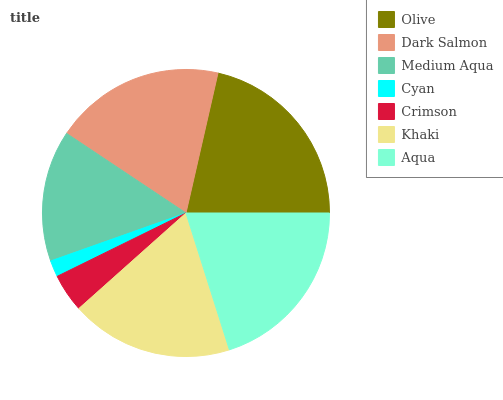Is Cyan the minimum?
Answer yes or no. Yes. Is Olive the maximum?
Answer yes or no. Yes. Is Dark Salmon the minimum?
Answer yes or no. No. Is Dark Salmon the maximum?
Answer yes or no. No. Is Olive greater than Dark Salmon?
Answer yes or no. Yes. Is Dark Salmon less than Olive?
Answer yes or no. Yes. Is Dark Salmon greater than Olive?
Answer yes or no. No. Is Olive less than Dark Salmon?
Answer yes or no. No. Is Khaki the high median?
Answer yes or no. Yes. Is Khaki the low median?
Answer yes or no. Yes. Is Dark Salmon the high median?
Answer yes or no. No. Is Cyan the low median?
Answer yes or no. No. 